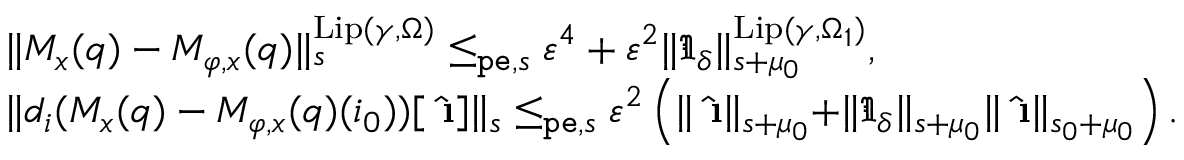<formula> <loc_0><loc_0><loc_500><loc_500>\begin{array} { r l } & { \| M _ { x } ( q ) - M _ { \varphi , x } ( q ) \| _ { s } ^ { L i p ( \gamma , \Omega ) } \leq _ { p e , s } \varepsilon ^ { 4 } + \varepsilon ^ { 2 } \| \mathfrak { I } _ { \delta } \| _ { s + \mu _ { 0 } } ^ { L i p ( \gamma , \Omega _ { 1 } ) } , } \\ & { \| d _ { i } ( M _ { x } ( q ) - M _ { \varphi , x } ( q ) ( i _ { 0 } ) ) [ \hat { \i } ] \| _ { s } \leq _ { p e , s } \varepsilon ^ { 2 } \left ( \| \hat { \i } \| _ { s + \mu _ { 0 } } + \| \mathfrak { I } _ { \delta } \| _ { s + \mu _ { 0 } } \| \hat { \i } \| _ { s _ { 0 } + \mu _ { 0 } } \right ) . } \end{array}</formula> 